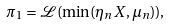Convert formula to latex. <formula><loc_0><loc_0><loc_500><loc_500>\pi _ { 1 } = \mathcal { L } ( \min ( \eta _ { n } X , \mu _ { n } ) ) ,</formula> 